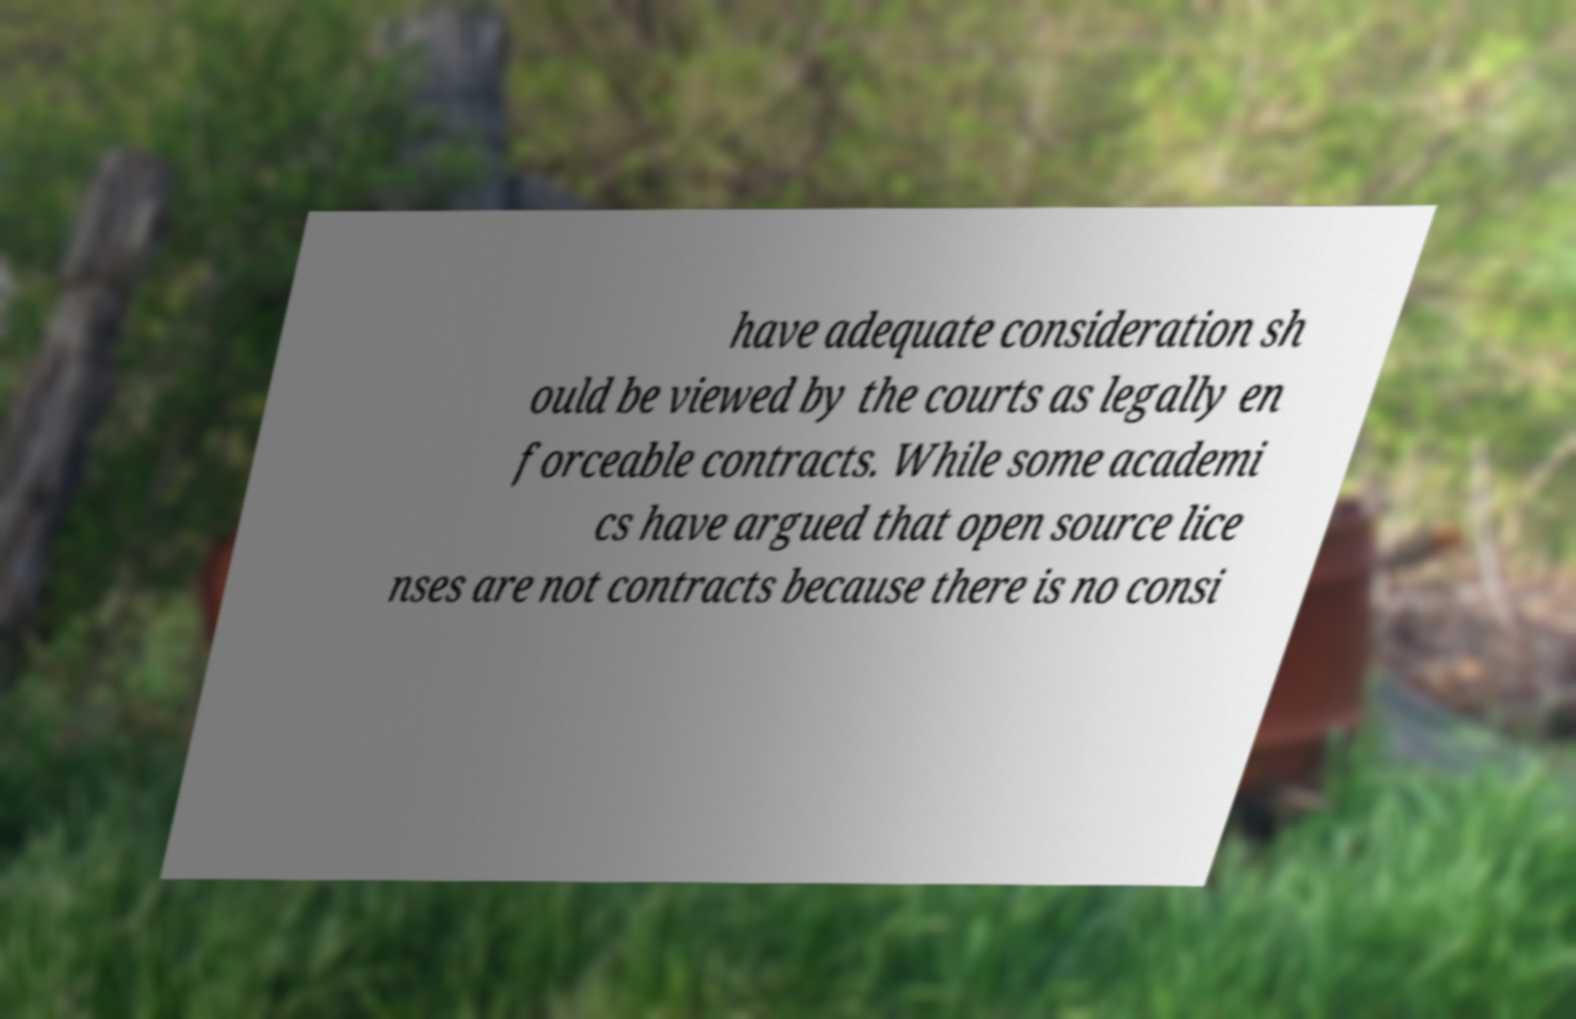Could you extract and type out the text from this image? have adequate consideration sh ould be viewed by the courts as legally en forceable contracts. While some academi cs have argued that open source lice nses are not contracts because there is no consi 